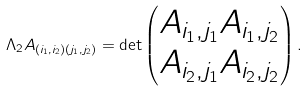Convert formula to latex. <formula><loc_0><loc_0><loc_500><loc_500>\Lambda _ { 2 } A _ { ( i _ { 1 } , i _ { 2 } ) ( j _ { 1 } , j _ { 2 } ) } = \det \begin{pmatrix} A _ { i _ { 1 } , j _ { 1 } } A _ { i _ { 1 } , j _ { 2 } } \\ A _ { i _ { 2 } , j _ { 1 } } A _ { i _ { 2 } , j _ { 2 } } \end{pmatrix} .</formula> 